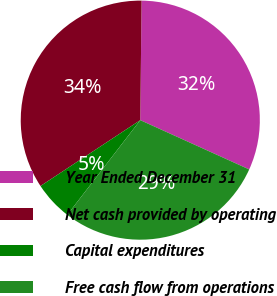Convert chart to OTSL. <chart><loc_0><loc_0><loc_500><loc_500><pie_chart><fcel>Year Ended December 31<fcel>Net cash provided by operating<fcel>Capital expenditures<fcel>Free cash flow from operations<nl><fcel>31.59%<fcel>34.46%<fcel>5.26%<fcel>28.69%<nl></chart> 